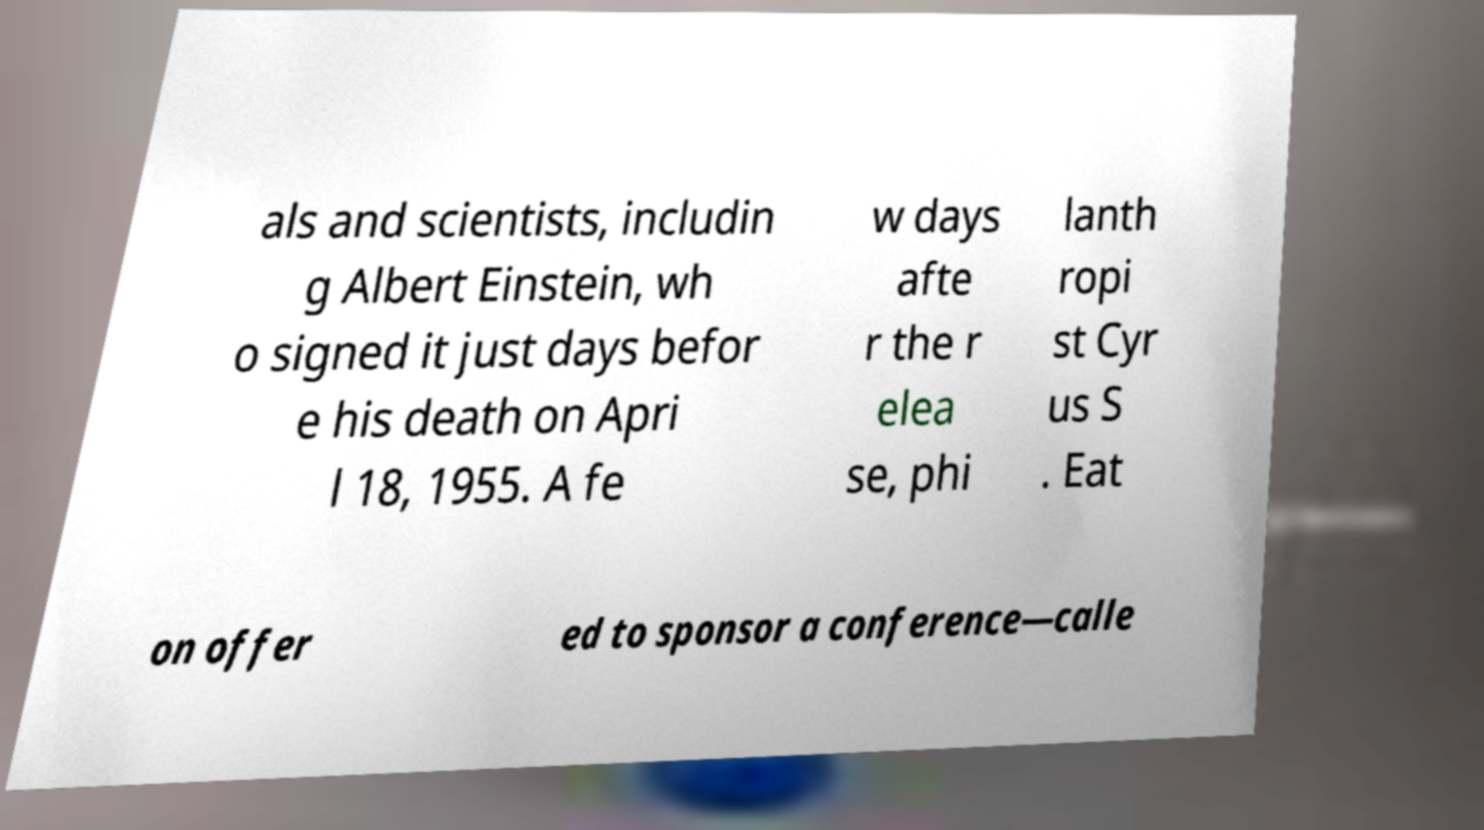I need the written content from this picture converted into text. Can you do that? als and scientists, includin g Albert Einstein, wh o signed it just days befor e his death on Apri l 18, 1955. A fe w days afte r the r elea se, phi lanth ropi st Cyr us S . Eat on offer ed to sponsor a conference—calle 